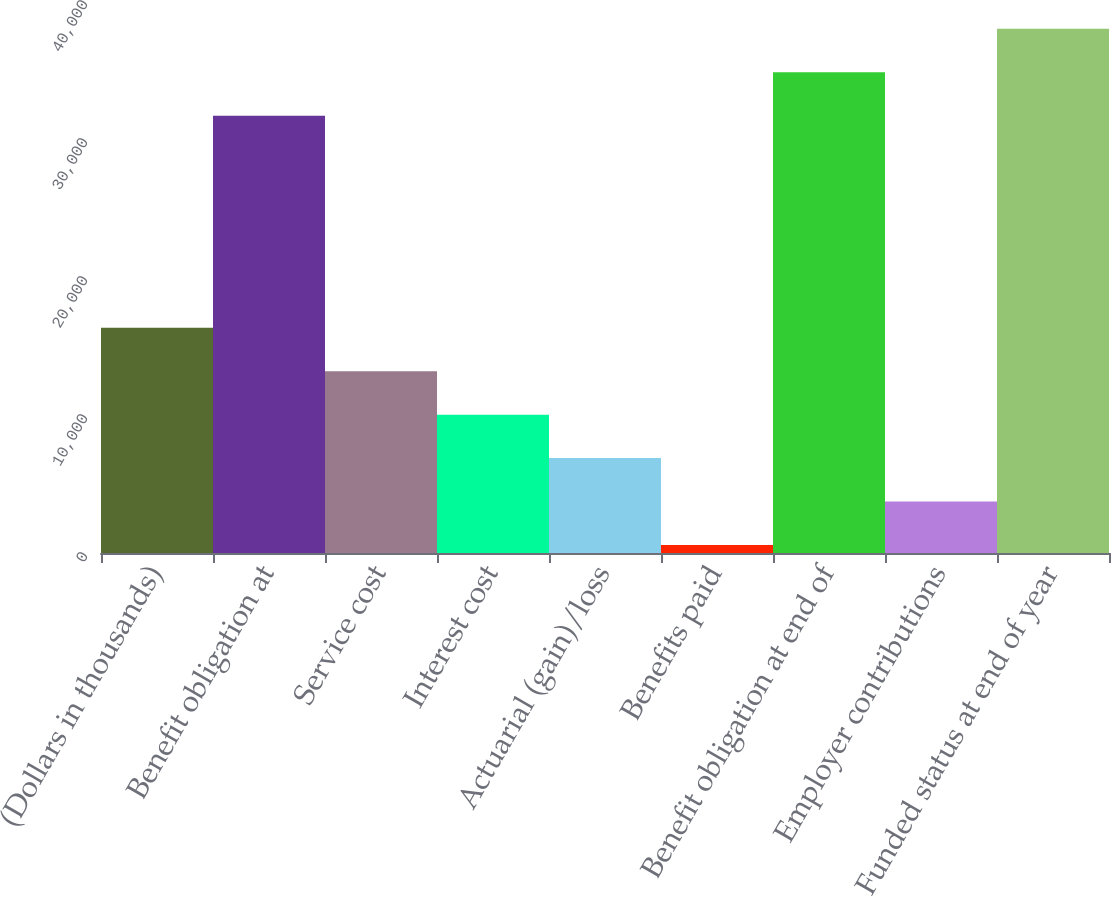Convert chart. <chart><loc_0><loc_0><loc_500><loc_500><bar_chart><fcel>(Dollars in thousands)<fcel>Benefit obligation at<fcel>Service cost<fcel>Interest cost<fcel>Actuarial (gain)/loss<fcel>Benefits paid<fcel>Benefit obligation at end of<fcel>Employer contributions<fcel>Funded status at end of year<nl><fcel>16325<fcel>31687<fcel>13175.8<fcel>10026.6<fcel>6877.4<fcel>579<fcel>34836.2<fcel>3728.2<fcel>37985.4<nl></chart> 